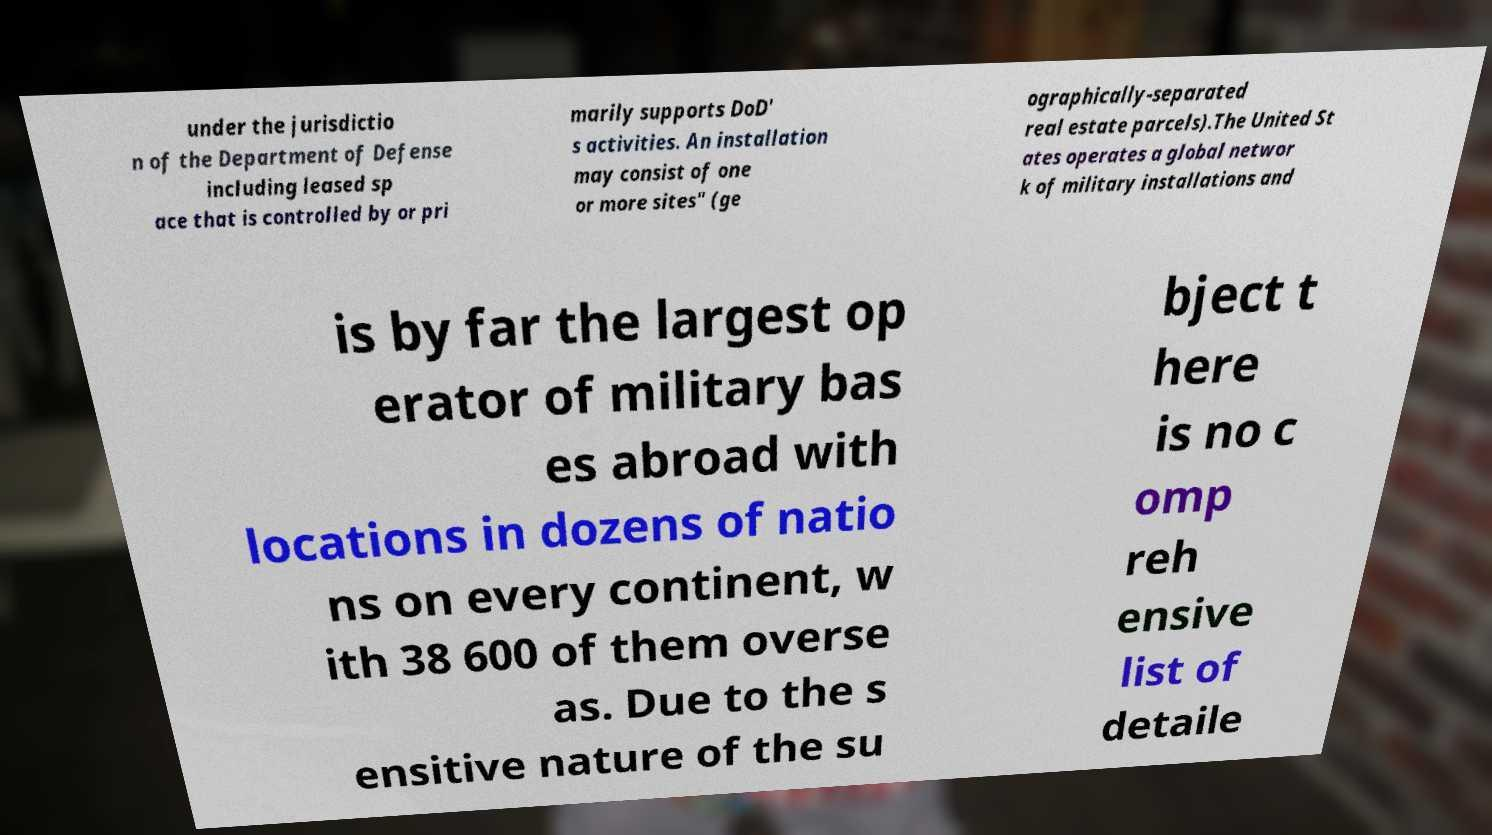What messages or text are displayed in this image? I need them in a readable, typed format. under the jurisdictio n of the Department of Defense including leased sp ace that is controlled by or pri marily supports DoD' s activities. An installation may consist of one or more sites" (ge ographically-separated real estate parcels).The United St ates operates a global networ k of military installations and is by far the largest op erator of military bas es abroad with locations in dozens of natio ns on every continent, w ith 38 600 of them overse as. Due to the s ensitive nature of the su bject t here is no c omp reh ensive list of detaile 